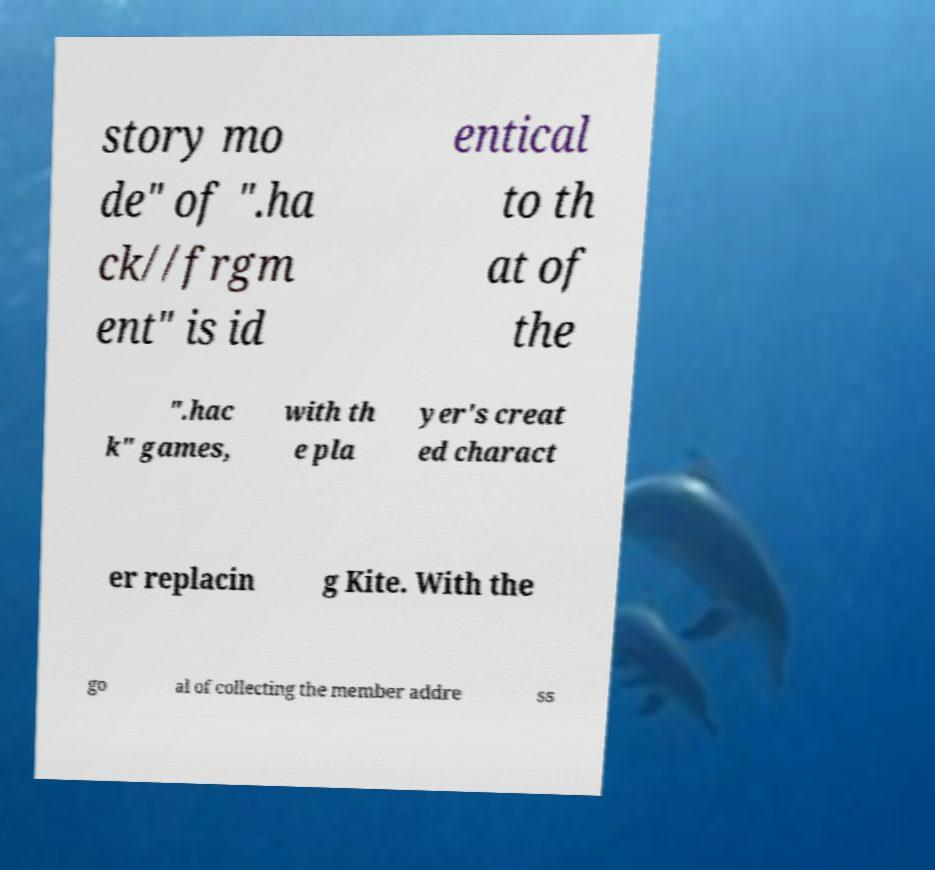Could you assist in decoding the text presented in this image and type it out clearly? story mo de" of ".ha ck//frgm ent" is id entical to th at of the ".hac k" games, with th e pla yer's creat ed charact er replacin g Kite. With the go al of collecting the member addre ss 